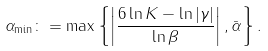<formula> <loc_0><loc_0><loc_500><loc_500>\alpha _ { \min } \colon = \max \left \{ \left | \frac { 6 \ln K - \ln | \gamma | } { \ln \beta } \right | , \bar { \alpha } \right \} .</formula> 